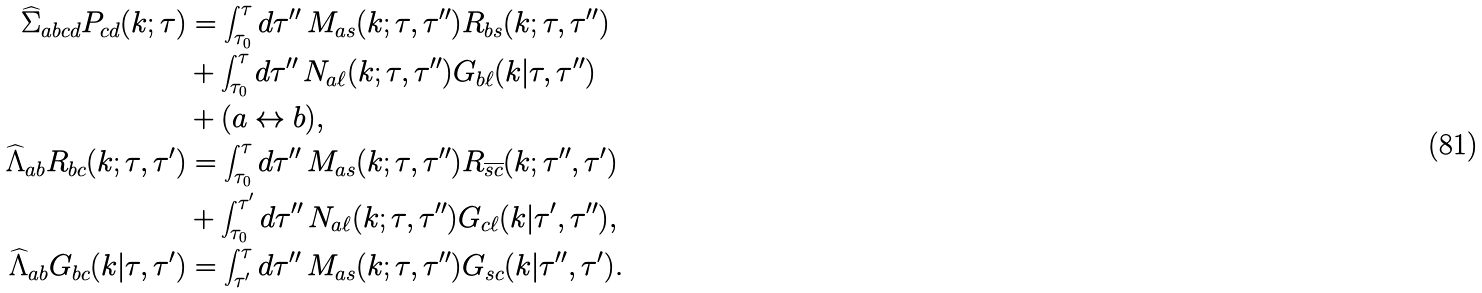Convert formula to latex. <formula><loc_0><loc_0><loc_500><loc_500>\widehat { \Sigma } _ { a b c d } P _ { c d } ( k ; \tau ) & = \int ^ { \tau } _ { \tau _ { 0 } } d \tau ^ { \prime \prime } \, M _ { a s } ( k ; \tau , \tau ^ { \prime \prime } ) R _ { b s } ( k ; \tau , \tau ^ { \prime \prime } ) \\ & + \int ^ { \tau } _ { \tau _ { 0 } } d \tau ^ { \prime \prime } \, N _ { a \ell } ( k ; \tau , \tau ^ { \prime \prime } ) G _ { b \ell } ( k | \tau , \tau ^ { \prime \prime } ) \\ & + ( a \leftrightarrow b ) , \\ \widehat { \Lambda } _ { a b } R _ { b c } ( k ; \tau , \tau ^ { \prime } ) & = \int ^ { \tau } _ { \tau _ { 0 } } d \tau ^ { \prime \prime } \, M _ { a s } ( k ; \tau , \tau ^ { \prime \prime } ) R _ { \overline { s c } } ( k ; \tau ^ { \prime \prime } , \tau ^ { \prime } ) \\ & + \int ^ { \tau ^ { \prime } } _ { \tau _ { 0 } } d \tau ^ { \prime \prime } \, N _ { a \ell } ( k ; \tau , \tau ^ { \prime \prime } ) G _ { c \ell } ( k | \tau ^ { \prime } , \tau ^ { \prime \prime } ) , \\ \widehat { \Lambda } _ { a b } G _ { b c } ( k | \tau , \tau ^ { \prime } ) & = \int ^ { \tau } _ { \tau ^ { \prime } } d \tau ^ { \prime \prime } \, M _ { a s } ( k ; \tau , \tau ^ { \prime \prime } ) G _ { s c } ( k | \tau ^ { \prime \prime } , \tau ^ { \prime } ) .</formula> 